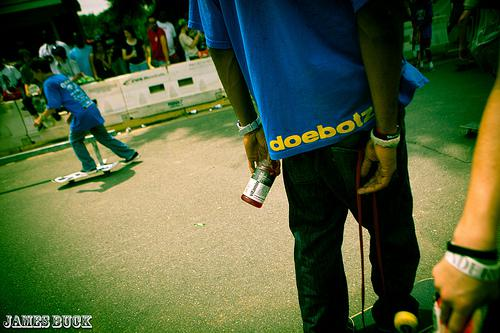Question: when was the picture taken?
Choices:
A. In the morning.
B. At midnight.
C. During free time.
D. During a competition.
Answer with the letter. Answer: D Question: where are the onlookers?
Choices:
A. In the park.
B. In the field.
C. On the street.
D. Behind the wall.
Answer with the letter. Answer: D Question: what is the boy on the skateboard doing?
Choices:
A. Jumping.
B. Dancing.
C. Falling.
D. Competing.
Answer with the letter. Answer: D Question: who is in the picture?
Choices:
A. Skaters.
B. Dancers.
C. Business men.
D. Ladies.
Answer with the letter. Answer: A 